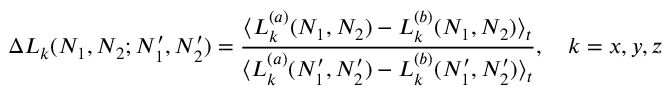Convert formula to latex. <formula><loc_0><loc_0><loc_500><loc_500>\Delta L _ { k } ( N _ { 1 } , N _ { 2 } ; N _ { 1 } ^ { \prime } , N _ { 2 } ^ { \prime } ) = \frac { \langle L _ { k } ^ { ( a ) } ( N _ { 1 } , N _ { 2 } ) - L _ { k } ^ { ( b ) } ( N _ { 1 } , N _ { 2 } ) \rangle _ { t } } { \langle L _ { k } ^ { ( a ) } ( N _ { 1 } ^ { \prime } , N _ { 2 } ^ { \prime } ) - L _ { k } ^ { ( b ) } ( N _ { 1 } ^ { \prime } , N _ { 2 } ^ { \prime } ) \rangle _ { t } } , \quad k = x , y , z</formula> 